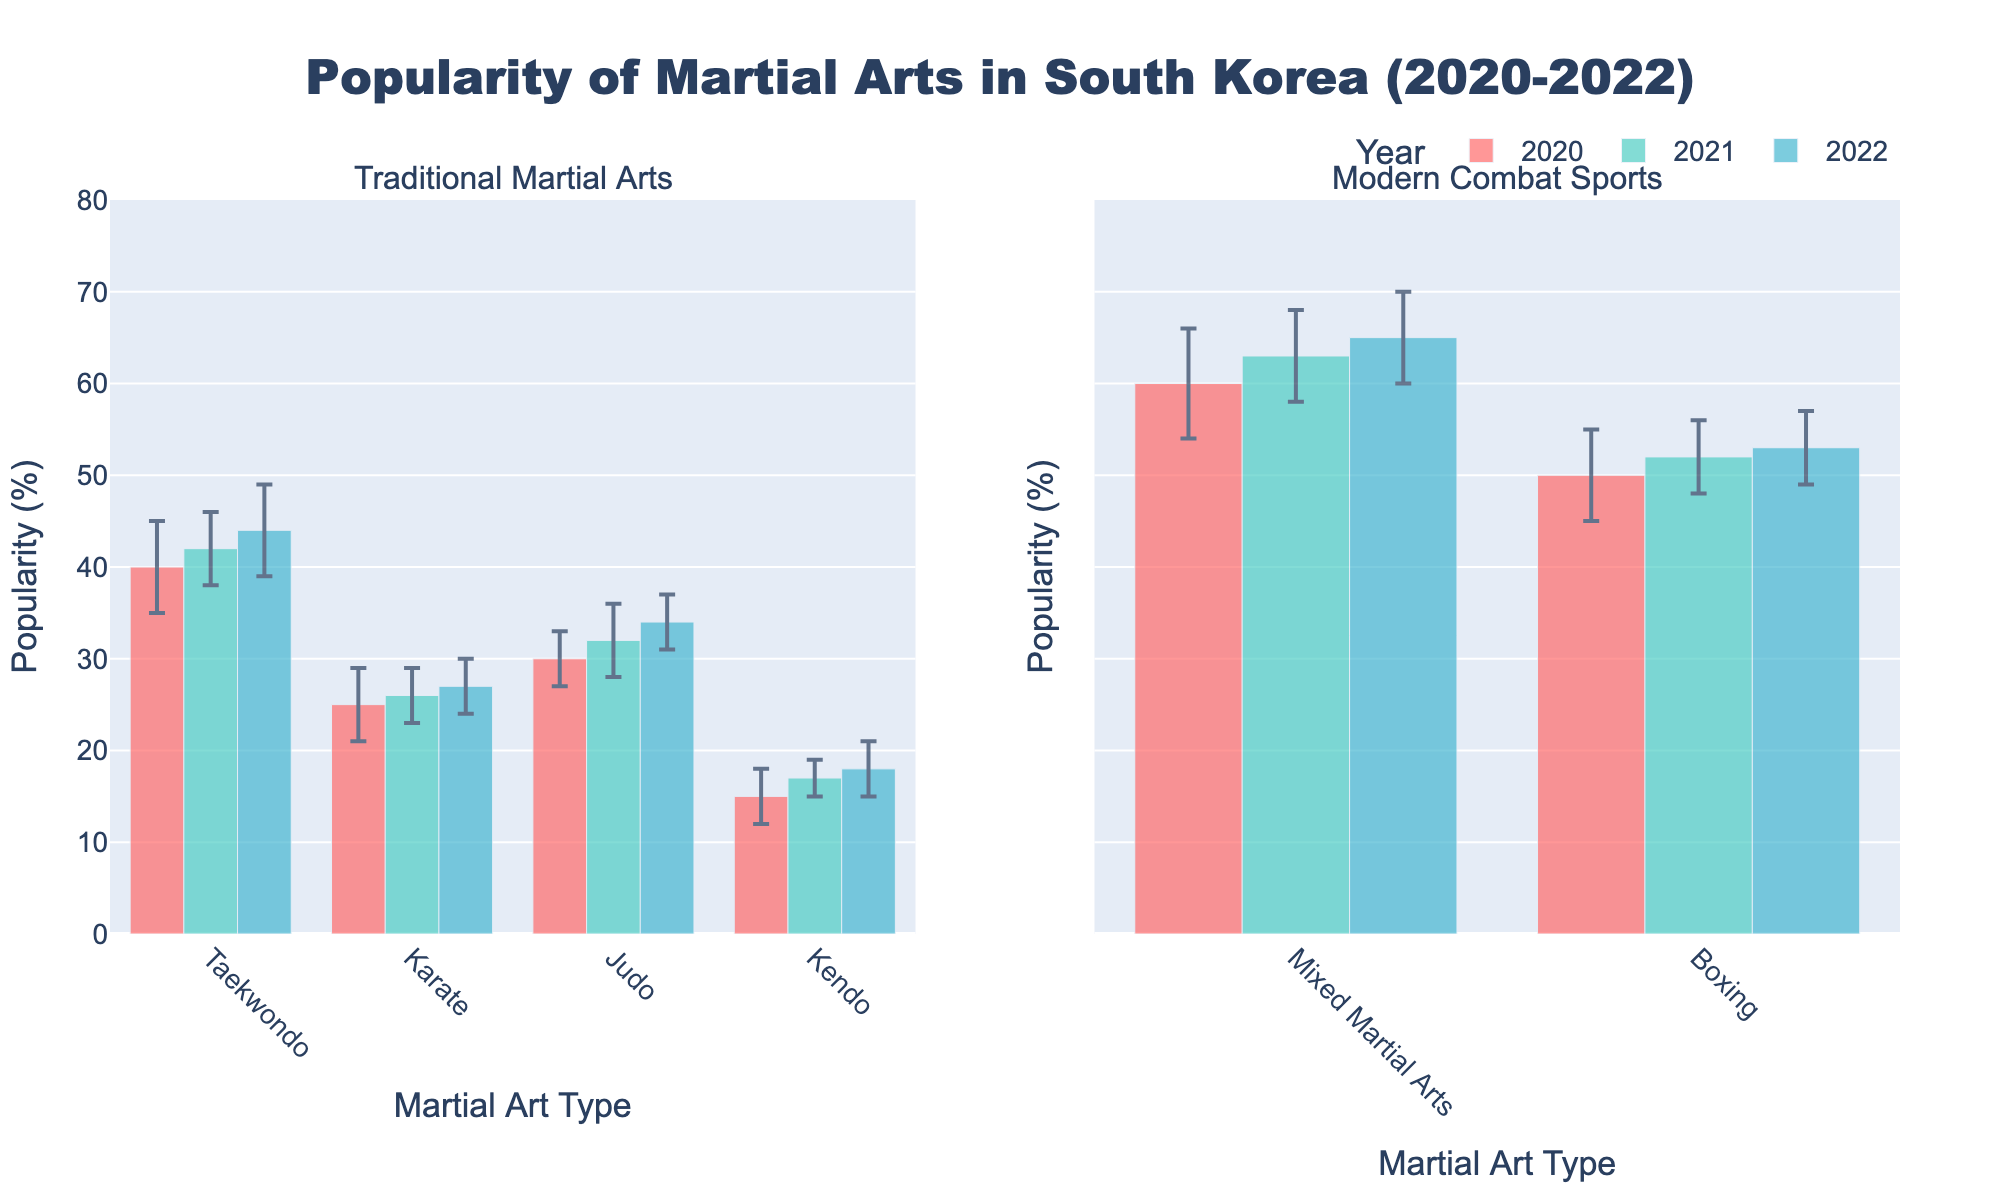What is the title of the plot? The title is displayed at the top of the figure in bold text. Reading it directly gives the information that the title conveys.
Answer: Popularity of Martial Arts in South Korea (2020-2022) How many types of martial arts are shown in the traditional category? By looking at the x-axis labels in the first subplot under "Traditional Martial Arts," we can count the number of different martial arts types.
Answer: 4 Which martial art had the highest popularity in 2020? To find this, look for the bar with the greatest height in the cluster corresponding to the year 2020 in both subplots. Mixed Martial Arts has the highest bar in 2020.
Answer: Mixed Martial Arts How much did the popularity of Boxing change from 2020 to 2022? Subtract the popularity value of Boxing in 2020 from its popularity value in 2022. From the figure, in 2020, Boxing has a popularity of 50, and in 2022, it's 53. Calculation: 53 - 50 = 3.
Answer: 3 Which traditional martial art showed the least variability in popularity over the three years? Look at the error bars of all traditional martial arts across the three years. The one with the shortest and most consistent error bars indicates the least variability. Judging by the error bars, Karate has the least variability.
Answer: Karate For the year 2021, which modern combat sport had a higher popularity? In the subplot for "Modern Combat Sports" for the year 2021, compare the heights of the bars representing Boxing and Mixed Martial Arts. Mixed Martial Arts has a higher bar than Boxing.
Answer: Mixed Martial Arts What is the average popularity of Taekwondo over the three years? Sum the popularity percentages of Taekwondo across the three years and divide by 3. Calculation: (40 + 42 + 44) / 3 = 126 / 3.
Answer: 42 Between 2020 and 2022, which martial art showed the most significant increase in popularity? Compare the change in popularity by subtracting the 2020 value from the 2022 value for all martial arts and find the one with the highest difference. Calculation for each: Taekwondo (44-40), Karate (27-25), Judo (34-30), Kendo (18-15), Mixed Martial Arts (65-60), Boxing (53-50). The highest increase is for Mixed Martial Arts (5).
Answer: Mixed Martial Arts What was the popularity of Judo in 2021, and how does it compare to the popularity of Judo in 2020? Check the height of the Judo bar in 2021 and 2020. In 2021, Judo's popularity is 32, while in 2020, it is 30. By comparing these values, we see that there is an increase of 2.
Answer: 32, increased by 2 